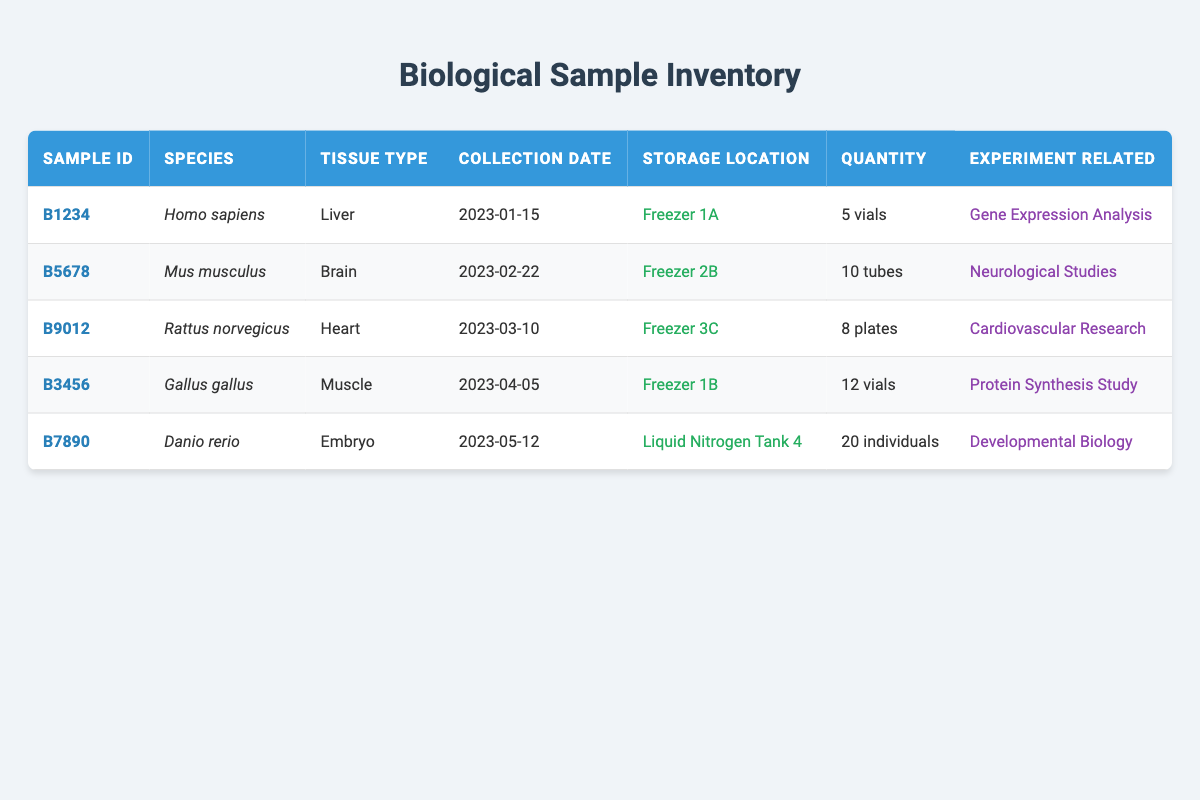What is the storage location of sample B5678? The storage location is listed directly in the table next to the sample ID B5678. Referring to the row for B5678, the storage location is "Freezer 2B."
Answer: Freezer 2B How many vials of the Homo sapiens liver sample are available? Looking at the row with sample ID B1234, the quantity is specified as 5 vials.
Answer: 5 vials Which species has the highest quantity of samples stored? To determine this, we can compare the quantities of all samples listed. The quantities are: 5 (Homo sapiens), 10 (Mus musculus), 8 (Rattus norvegicus), 12 (Gallus gallus), and 20 (Danio rerio). The highest quantity is 20 individuals for the Danio rerio.
Answer: Danio rerio Is there a sample from Rattus norvegicus collected before March 15, 2023? We check the collection date for the sample with species Rattus norvegicus, which is March 10, 2023, which is before March 15, 2023. Therefore, the answer is yes.
Answer: Yes What is the total quantity of all samples stored in vials? We sum the quantities of all samples stored in vials. The relevant samples are B1234 with 5 vials and B3456 with 12 vials. The total is 5 + 12 = 17 vials.
Answer: 17 vials How many individual embryos of Danio rerio are stored? The quantity of individuals of Danio rerio is listed in the respective row, which is 20 individuals.
Answer: 20 individuals Which experiment is related to the sample stored in Freezer 3C? Looking at the row for sample ID B9012, which is stored in Freezer 3C, it is associated with the "Cardiovascular Research" experiment as indicated in the table.
Answer: Cardiovascular Research How many samples were collected after April 1, 2023? We examine the collection dates for all samples. The samples and their collection dates are: B5678 (February 22, 2023), B9012 (March 10, 2023), B3456 (April 5, 2023), and B7890 (May 12, 2023). Only samples B3456 (April 5) and B7890 (May 12) meet the criteria, totaling 2 samples.
Answer: 2 samples Was any sample collected in January 2023? The only sample from January is B1234, which has a collection date of January 15, 2023. Therefore, the answer is yes.
Answer: Yes 